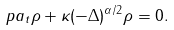<formula> <loc_0><loc_0><loc_500><loc_500>\ p a _ { t } \rho + \kappa ( - \Delta ) ^ { \alpha / 2 } \rho = 0 .</formula> 